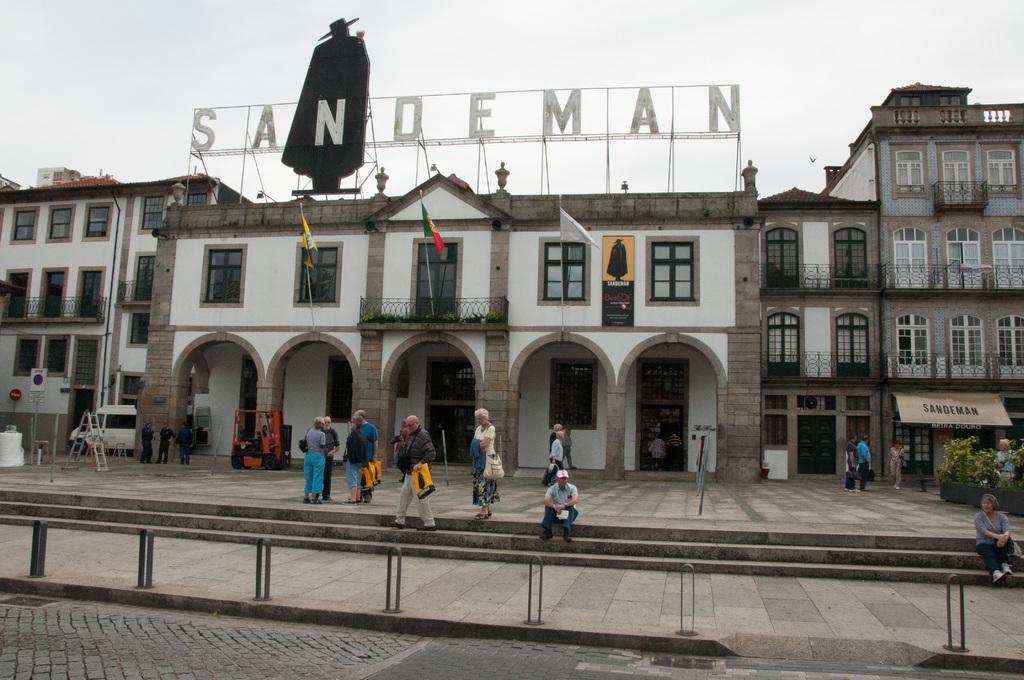How would you summarize this image in a sentence or two? In this picture there is a man who is sitting on the stairs. He is wearing cap, t-shirt, jeans and shoe. Beside him we can see a woman who is wearing t-shirt and holding a bag. Here we can see group of person standing near to the stairs. On the right there is a woman who is sitting near to the plants. In the background we can see buildings. On the top of the building we can see hotel name and black board. On the top we can see sky and clouds. On the bottom we can see fencing near to the road. On the left we can see stairs, ladders, sign boards, poles and car. 